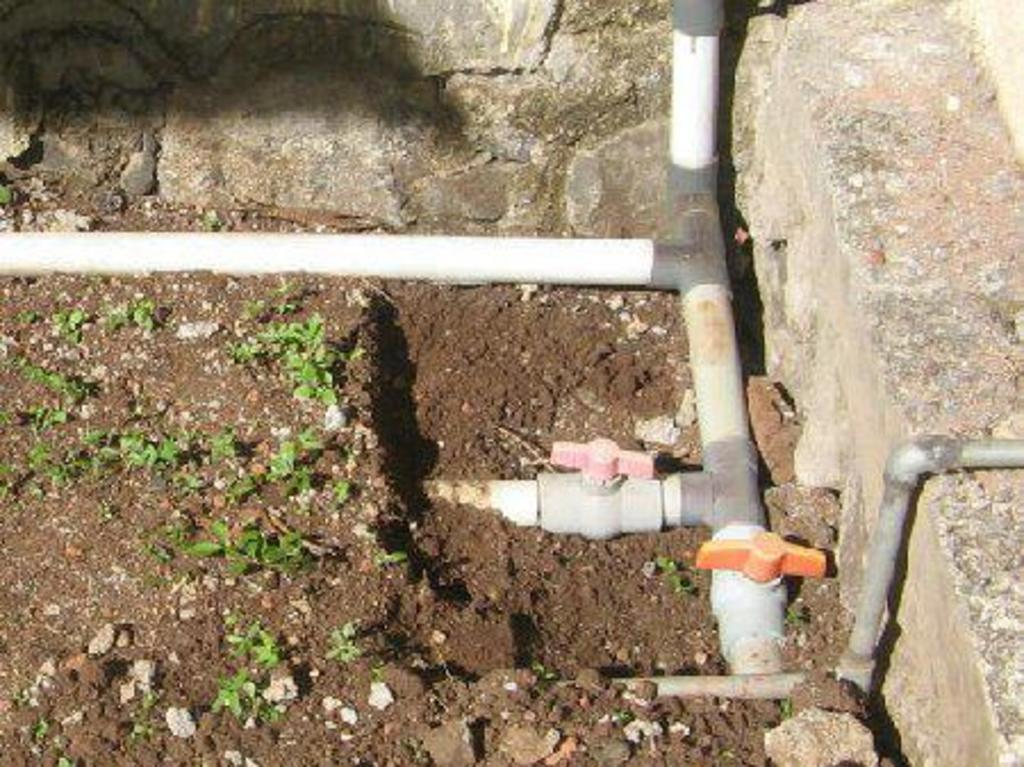What type of living organisms can be seen in the image? Plants can be seen in the image. What man-made objects are present in the image? Pipes are present in the image. How many kittens are running on the road in the image? There are no kittens or roads present in the image. 